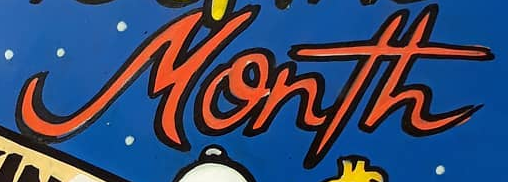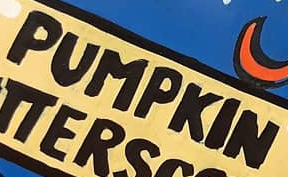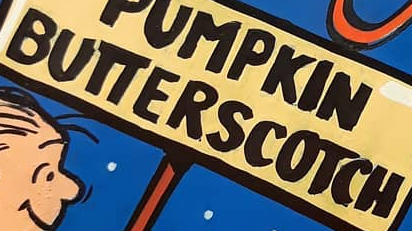What text appears in these images from left to right, separated by a semicolon? Month; PUMPKIN; BUTTERSCOTCH 